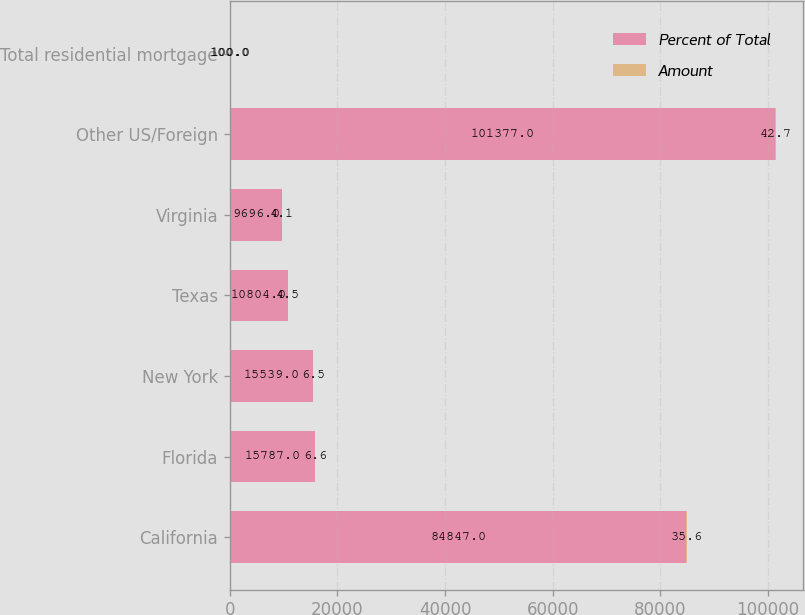Convert chart to OTSL. <chart><loc_0><loc_0><loc_500><loc_500><stacked_bar_chart><ecel><fcel>California<fcel>Florida<fcel>New York<fcel>Texas<fcel>Virginia<fcel>Other US/Foreign<fcel>Total residential mortgage<nl><fcel>Percent of Total<fcel>84847<fcel>15787<fcel>15539<fcel>10804<fcel>9696<fcel>101377<fcel>100<nl><fcel>Amount<fcel>35.6<fcel>6.6<fcel>6.5<fcel>4.5<fcel>4.1<fcel>42.7<fcel>100<nl></chart> 